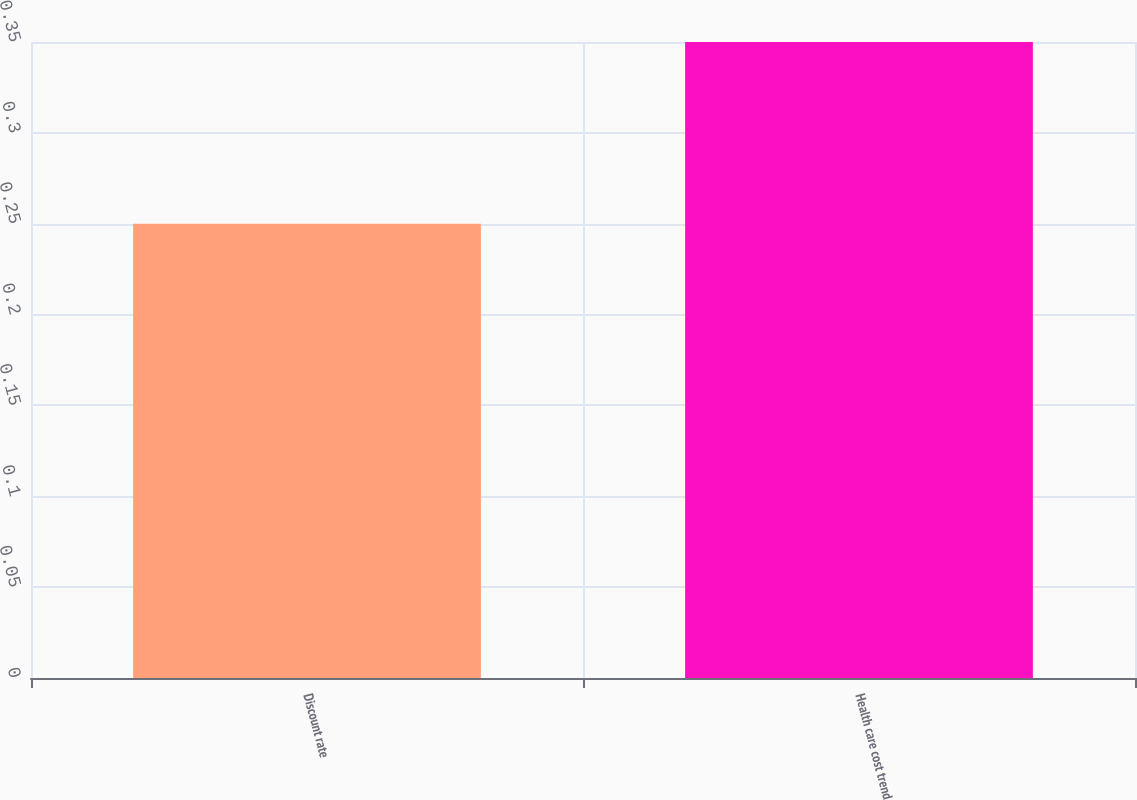Convert chart to OTSL. <chart><loc_0><loc_0><loc_500><loc_500><bar_chart><fcel>Discount rate<fcel>Health care cost trend<nl><fcel>0.25<fcel>0.35<nl></chart> 